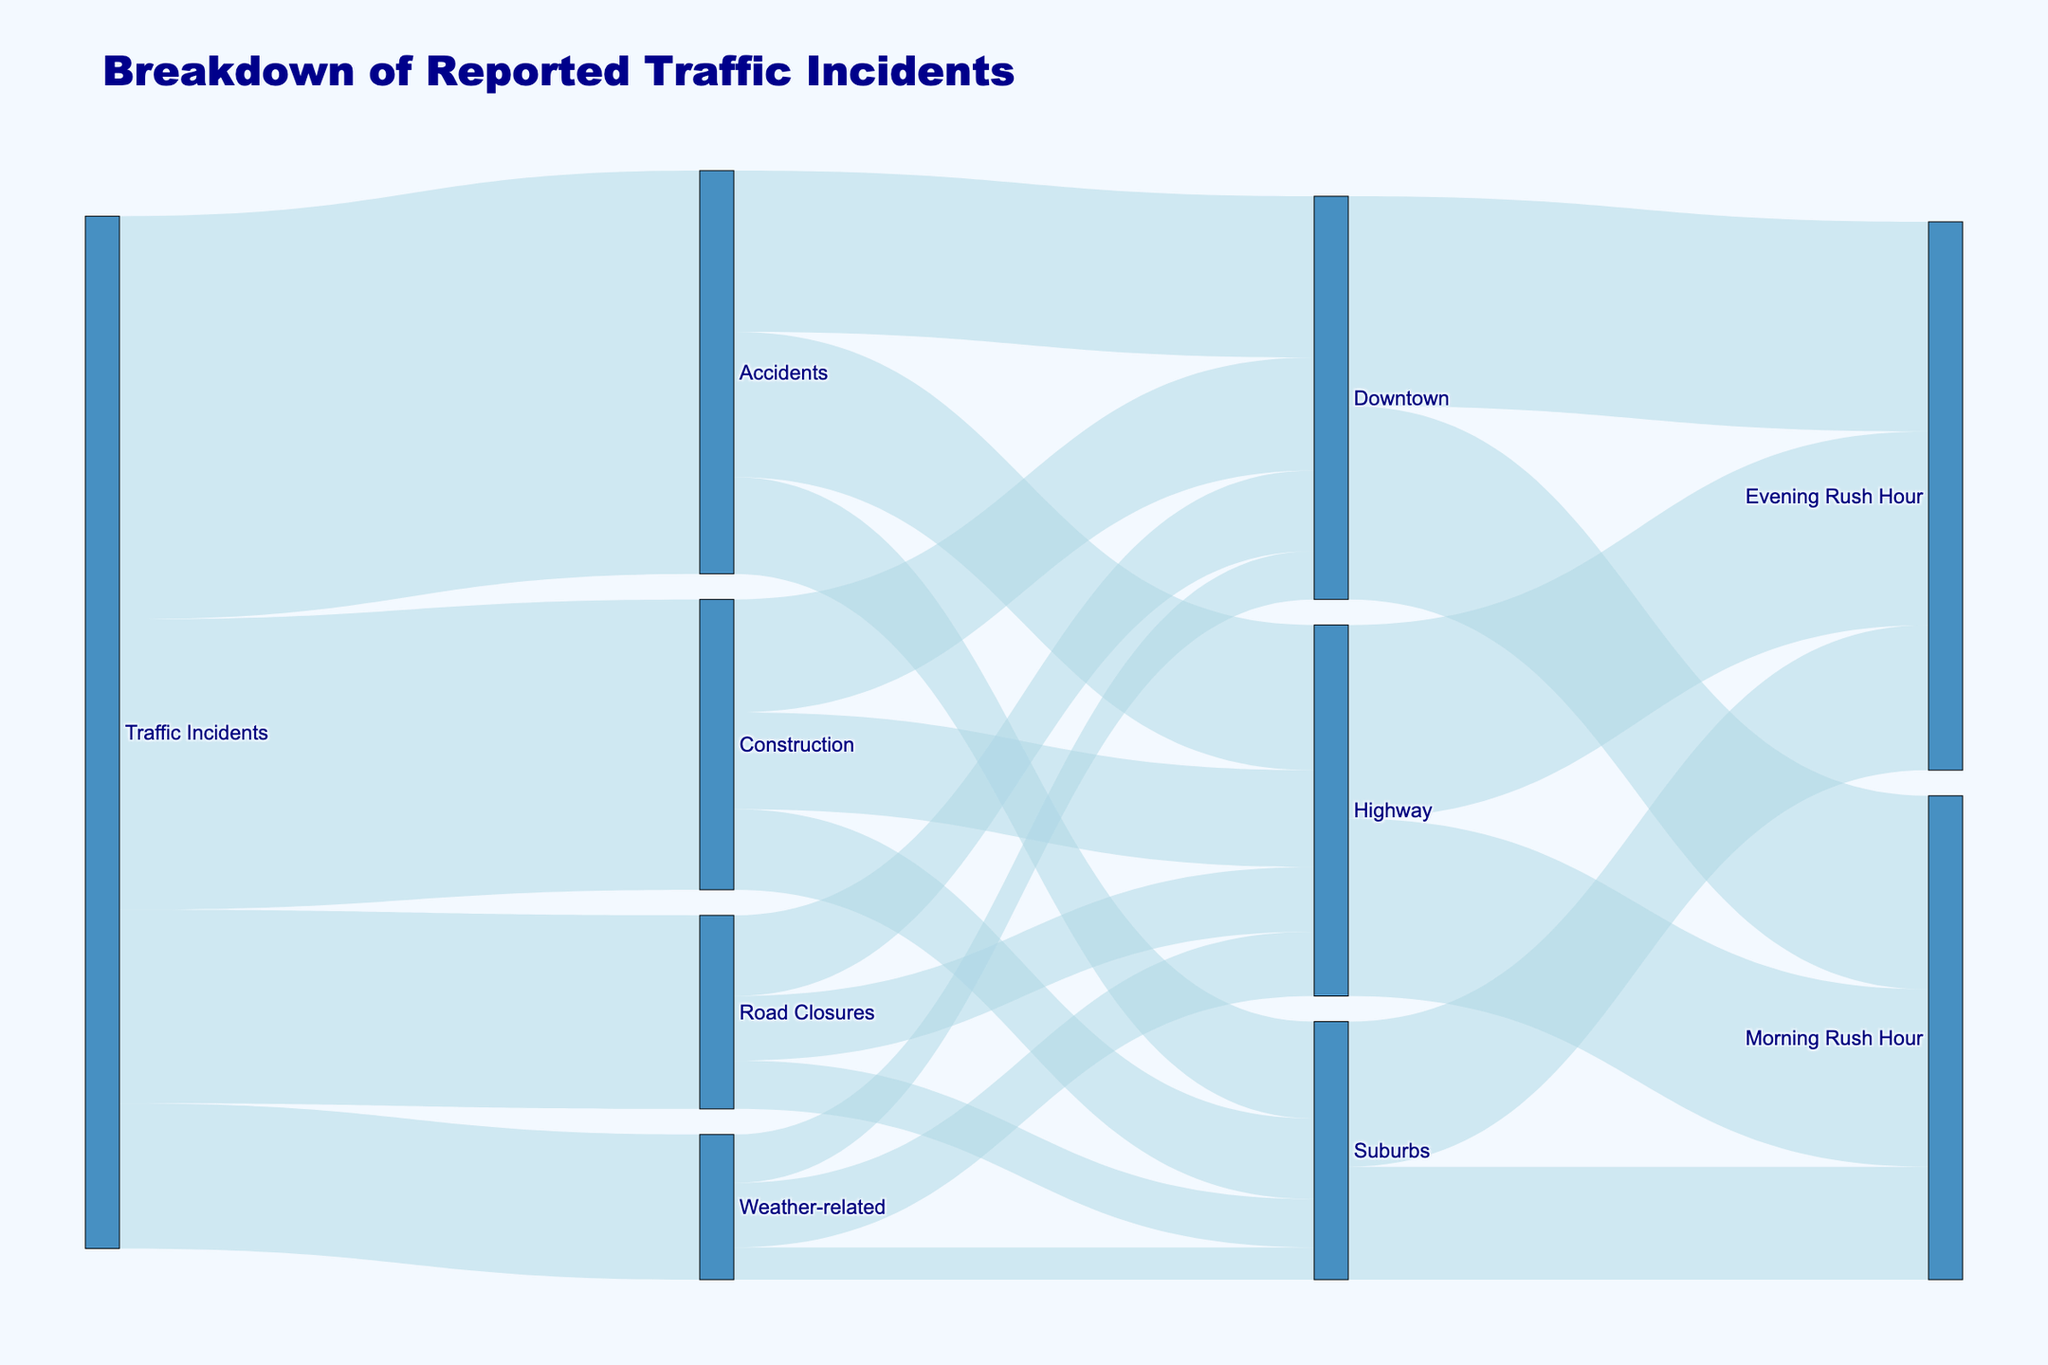What is the title of the figure? The title of a figure is typically displayed prominently at the top of the diagram. In this case, the title is intended to provide a summary of what the diagram represents.
Answer: Breakdown of Reported Traffic Incidents Which type of traffic incident has the highest occurrence? To find the traffic incident with the highest occurrence, look at the values connected directly to the "Traffic Incidents" node. The largest value corresponds to the type of traffic incident with the highest occurrence.
Answer: Accidents What is the total number of traffic incidents reported in the diagram? Add up all the values connected to the "Traffic Incidents" node. These values are 250 (Accidents) + 120 (Road Closures) + 180 (Construction) + 90 (Weather-related).
Answer: 640 Which location has the most accidents? To find this, look at the values connected to the "Accidents" node and compare them. The location with the highest value is the one with the most accidents.
Answer: Downtown How many incidents occurred during the Evening Rush Hour in the Suburbs? Look at the values connected to the "Suburbs" node and find the value that corresponds to the "Evening Rush Hour."
Answer: 90 What is the difference in the number of weather-related incidents between the Highway and Downtown? Subtract the number of weather-related incidents in Downtown (30) from the number of weather-related incidents in the Highway (40).
Answer: 10 Which type of incident has the least occurrence in the Suburbs? Look at the values connected to the "Suburbs" node and find the lowest value among the different types of incidents.
Answer: Weather-related Compare the number of incidents reported in the Downtown during Morning Rush Hour and Evening Rush Hour. Which period has more incidents? Look at the values linked to the "Downtown" node for Morning Rush Hour and Evening Rush Hour, then compare them. Morning Rush Hour has 120, and Evening Rush Hour has 130.
Answer: Evening Rush Hour How many more road closures are there in the Downtown compared to the Suburbs? Subtract the number of road closures in the Suburbs (30) from the number of road closures in the Downtown (50).
Answer: 20 